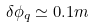Convert formula to latex. <formula><loc_0><loc_0><loc_500><loc_500>\delta \phi _ { q } \simeq 0 . 1 m</formula> 